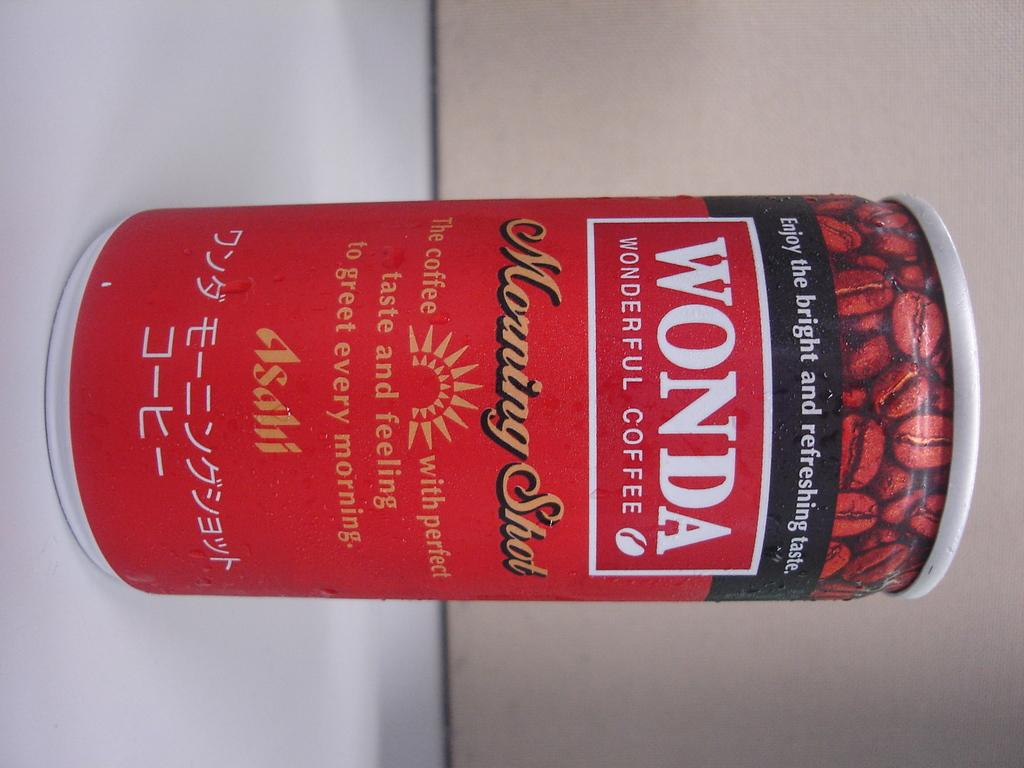<image>
Give a short and clear explanation of the subsequent image. Red can of Wonda showing some coffee beans on the top. 